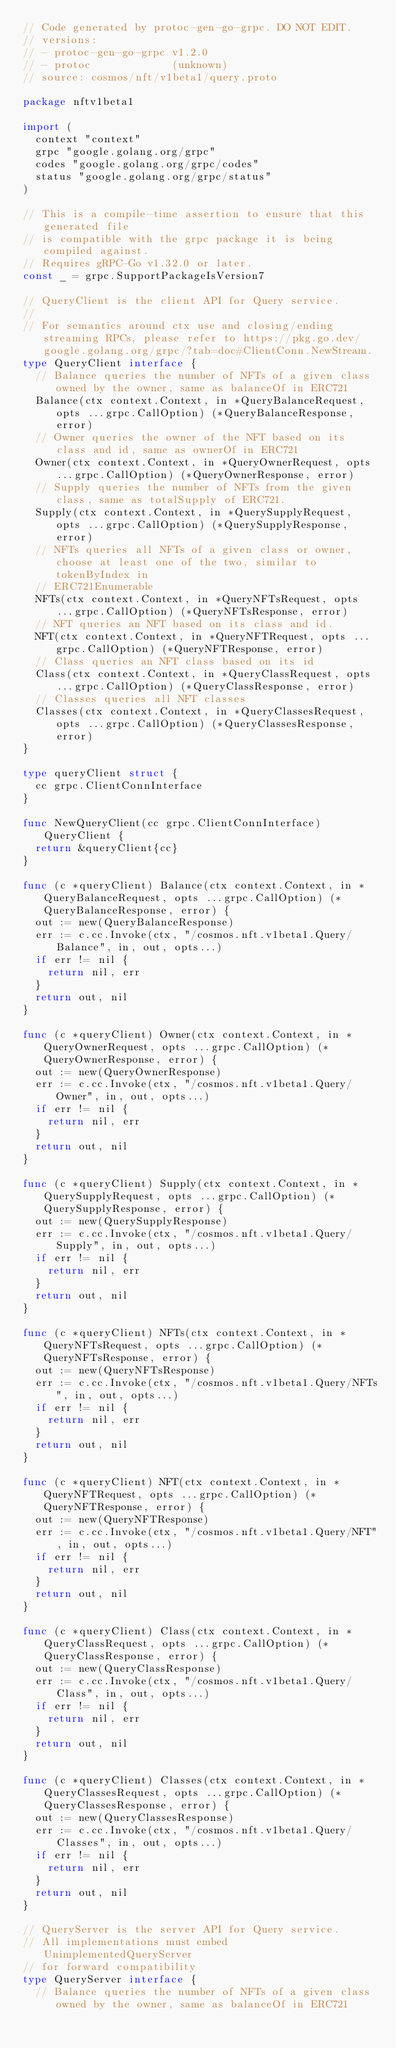Convert code to text. <code><loc_0><loc_0><loc_500><loc_500><_Go_>// Code generated by protoc-gen-go-grpc. DO NOT EDIT.
// versions:
// - protoc-gen-go-grpc v1.2.0
// - protoc             (unknown)
// source: cosmos/nft/v1beta1/query.proto

package nftv1beta1

import (
	context "context"
	grpc "google.golang.org/grpc"
	codes "google.golang.org/grpc/codes"
	status "google.golang.org/grpc/status"
)

// This is a compile-time assertion to ensure that this generated file
// is compatible with the grpc package it is being compiled against.
// Requires gRPC-Go v1.32.0 or later.
const _ = grpc.SupportPackageIsVersion7

// QueryClient is the client API for Query service.
//
// For semantics around ctx use and closing/ending streaming RPCs, please refer to https://pkg.go.dev/google.golang.org/grpc/?tab=doc#ClientConn.NewStream.
type QueryClient interface {
	// Balance queries the number of NFTs of a given class owned by the owner, same as balanceOf in ERC721
	Balance(ctx context.Context, in *QueryBalanceRequest, opts ...grpc.CallOption) (*QueryBalanceResponse, error)
	// Owner queries the owner of the NFT based on its class and id, same as ownerOf in ERC721
	Owner(ctx context.Context, in *QueryOwnerRequest, opts ...grpc.CallOption) (*QueryOwnerResponse, error)
	// Supply queries the number of NFTs from the given class, same as totalSupply of ERC721.
	Supply(ctx context.Context, in *QuerySupplyRequest, opts ...grpc.CallOption) (*QuerySupplyResponse, error)
	// NFTs queries all NFTs of a given class or owner,choose at least one of the two, similar to tokenByIndex in
	// ERC721Enumerable
	NFTs(ctx context.Context, in *QueryNFTsRequest, opts ...grpc.CallOption) (*QueryNFTsResponse, error)
	// NFT queries an NFT based on its class and id.
	NFT(ctx context.Context, in *QueryNFTRequest, opts ...grpc.CallOption) (*QueryNFTResponse, error)
	// Class queries an NFT class based on its id
	Class(ctx context.Context, in *QueryClassRequest, opts ...grpc.CallOption) (*QueryClassResponse, error)
	// Classes queries all NFT classes
	Classes(ctx context.Context, in *QueryClassesRequest, opts ...grpc.CallOption) (*QueryClassesResponse, error)
}

type queryClient struct {
	cc grpc.ClientConnInterface
}

func NewQueryClient(cc grpc.ClientConnInterface) QueryClient {
	return &queryClient{cc}
}

func (c *queryClient) Balance(ctx context.Context, in *QueryBalanceRequest, opts ...grpc.CallOption) (*QueryBalanceResponse, error) {
	out := new(QueryBalanceResponse)
	err := c.cc.Invoke(ctx, "/cosmos.nft.v1beta1.Query/Balance", in, out, opts...)
	if err != nil {
		return nil, err
	}
	return out, nil
}

func (c *queryClient) Owner(ctx context.Context, in *QueryOwnerRequest, opts ...grpc.CallOption) (*QueryOwnerResponse, error) {
	out := new(QueryOwnerResponse)
	err := c.cc.Invoke(ctx, "/cosmos.nft.v1beta1.Query/Owner", in, out, opts...)
	if err != nil {
		return nil, err
	}
	return out, nil
}

func (c *queryClient) Supply(ctx context.Context, in *QuerySupplyRequest, opts ...grpc.CallOption) (*QuerySupplyResponse, error) {
	out := new(QuerySupplyResponse)
	err := c.cc.Invoke(ctx, "/cosmos.nft.v1beta1.Query/Supply", in, out, opts...)
	if err != nil {
		return nil, err
	}
	return out, nil
}

func (c *queryClient) NFTs(ctx context.Context, in *QueryNFTsRequest, opts ...grpc.CallOption) (*QueryNFTsResponse, error) {
	out := new(QueryNFTsResponse)
	err := c.cc.Invoke(ctx, "/cosmos.nft.v1beta1.Query/NFTs", in, out, opts...)
	if err != nil {
		return nil, err
	}
	return out, nil
}

func (c *queryClient) NFT(ctx context.Context, in *QueryNFTRequest, opts ...grpc.CallOption) (*QueryNFTResponse, error) {
	out := new(QueryNFTResponse)
	err := c.cc.Invoke(ctx, "/cosmos.nft.v1beta1.Query/NFT", in, out, opts...)
	if err != nil {
		return nil, err
	}
	return out, nil
}

func (c *queryClient) Class(ctx context.Context, in *QueryClassRequest, opts ...grpc.CallOption) (*QueryClassResponse, error) {
	out := new(QueryClassResponse)
	err := c.cc.Invoke(ctx, "/cosmos.nft.v1beta1.Query/Class", in, out, opts...)
	if err != nil {
		return nil, err
	}
	return out, nil
}

func (c *queryClient) Classes(ctx context.Context, in *QueryClassesRequest, opts ...grpc.CallOption) (*QueryClassesResponse, error) {
	out := new(QueryClassesResponse)
	err := c.cc.Invoke(ctx, "/cosmos.nft.v1beta1.Query/Classes", in, out, opts...)
	if err != nil {
		return nil, err
	}
	return out, nil
}

// QueryServer is the server API for Query service.
// All implementations must embed UnimplementedQueryServer
// for forward compatibility
type QueryServer interface {
	// Balance queries the number of NFTs of a given class owned by the owner, same as balanceOf in ERC721</code> 